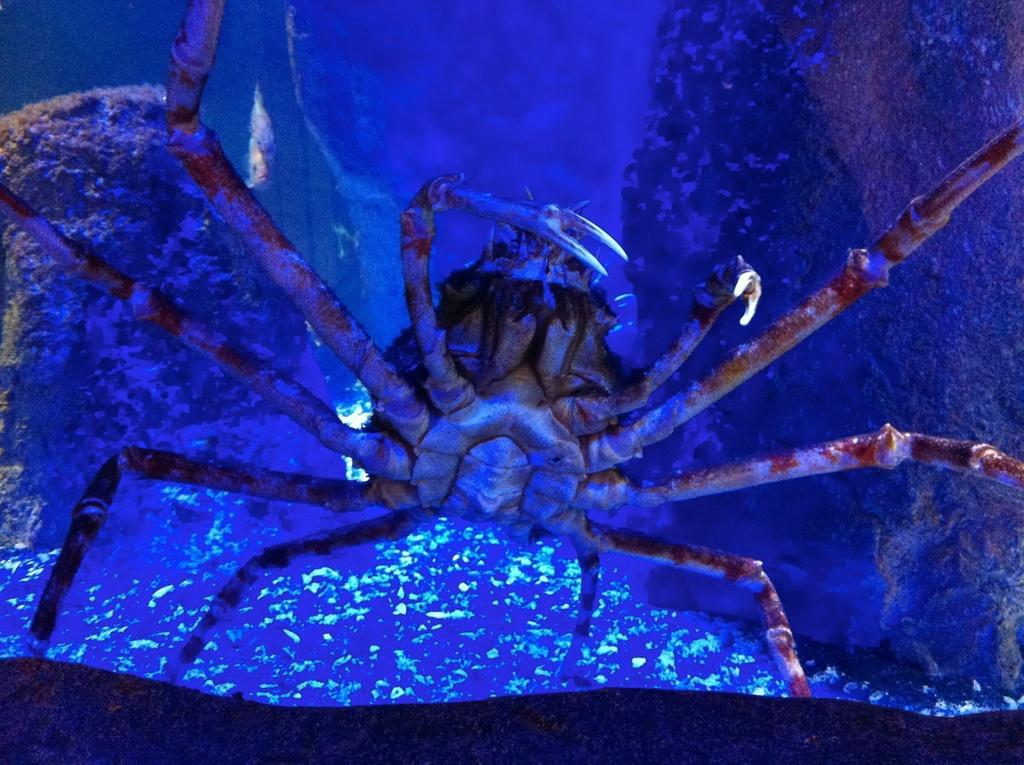What type of creature can be seen in the image? There is an insect in the image. What objects are present on the left and right sides of the image? There is a rock on the left side of the image and a rock on the right side of the image. What type of mass is present on the earth in the image? There is no reference to mass or the earth in the image; it features an insect and rocks. 